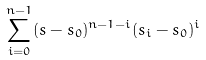<formula> <loc_0><loc_0><loc_500><loc_500>\sum _ { i = 0 } ^ { n - 1 } ( s - s _ { 0 } ) ^ { n - 1 - i } ( s _ { i } - s _ { 0 } ) ^ { i }</formula> 